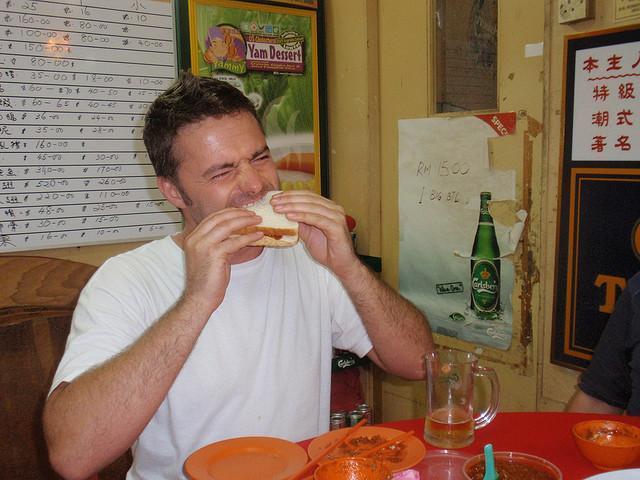How many orange dishes in the picture?
Give a very brief answer. 4. How many men are shown?
Give a very brief answer. 1. How many cups are in the picture?
Give a very brief answer. 1. How many bowls can you see?
Give a very brief answer. 4. How many people are in the picture?
Give a very brief answer. 2. How many yellow trucks are parked?
Give a very brief answer. 0. 